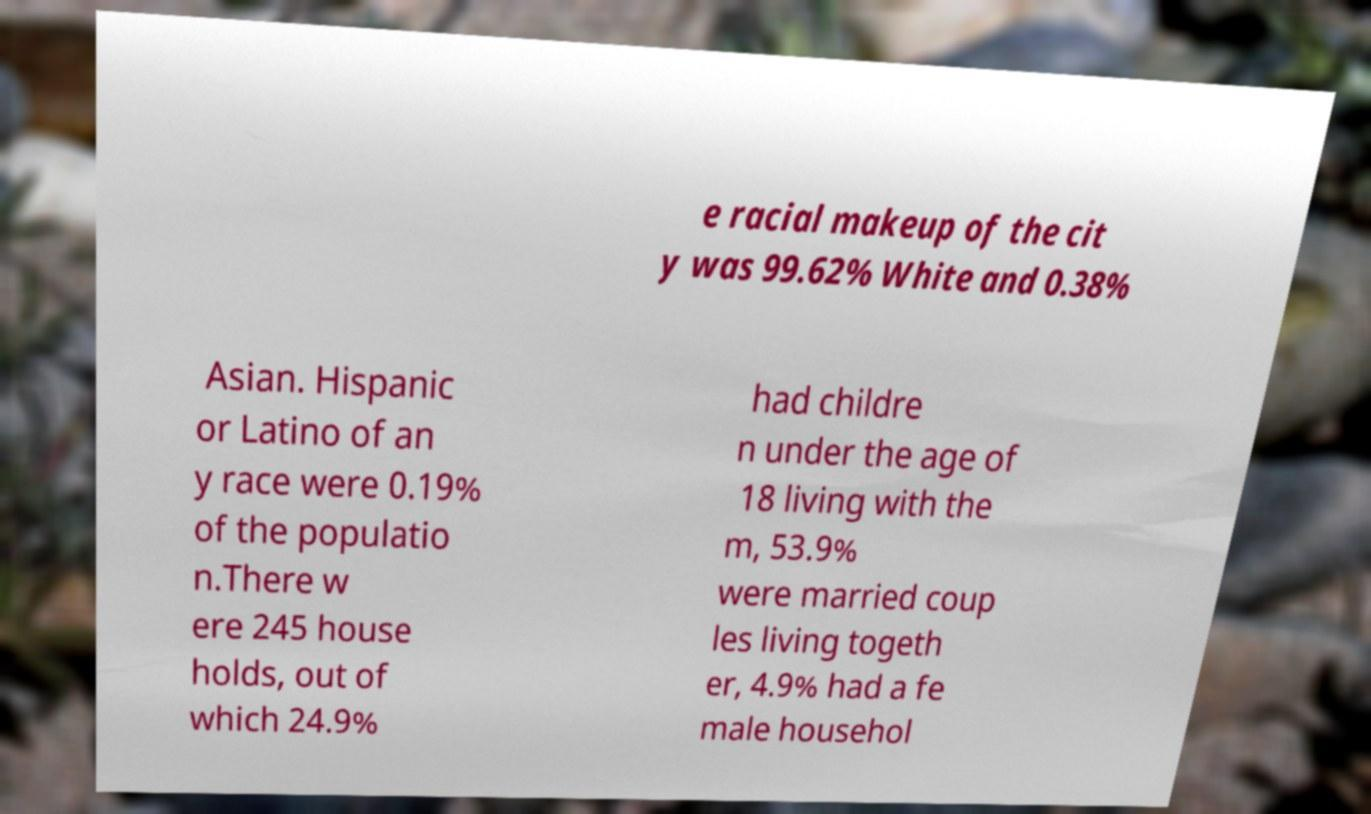Please identify and transcribe the text found in this image. e racial makeup of the cit y was 99.62% White and 0.38% Asian. Hispanic or Latino of an y race were 0.19% of the populatio n.There w ere 245 house holds, out of which 24.9% had childre n under the age of 18 living with the m, 53.9% were married coup les living togeth er, 4.9% had a fe male househol 